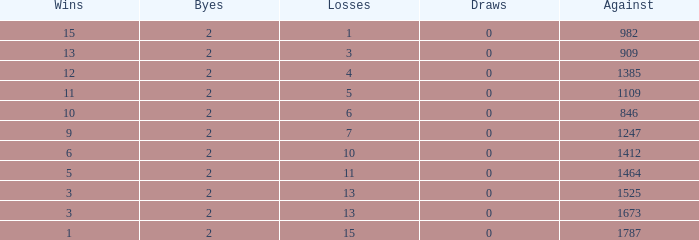What is the typical count of byes when there were below 0 losses and were against 1247? None. 